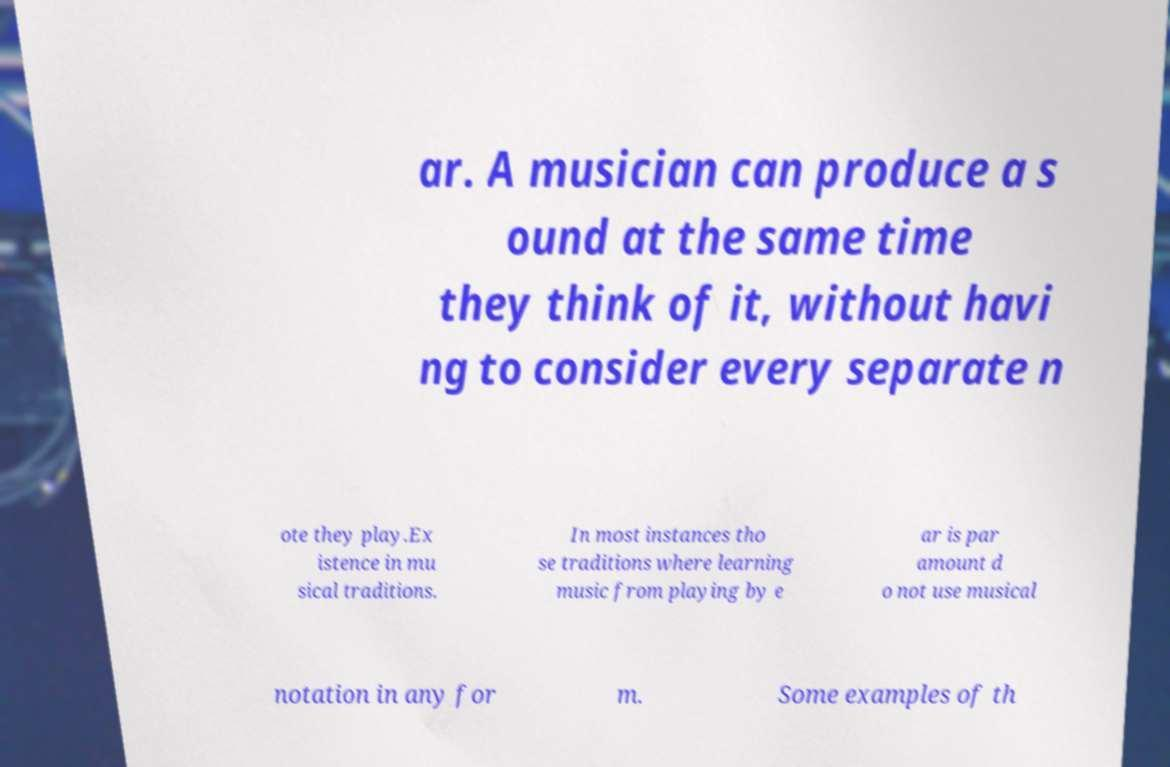Could you extract and type out the text from this image? ar. A musician can produce a s ound at the same time they think of it, without havi ng to consider every separate n ote they play.Ex istence in mu sical traditions. In most instances tho se traditions where learning music from playing by e ar is par amount d o not use musical notation in any for m. Some examples of th 